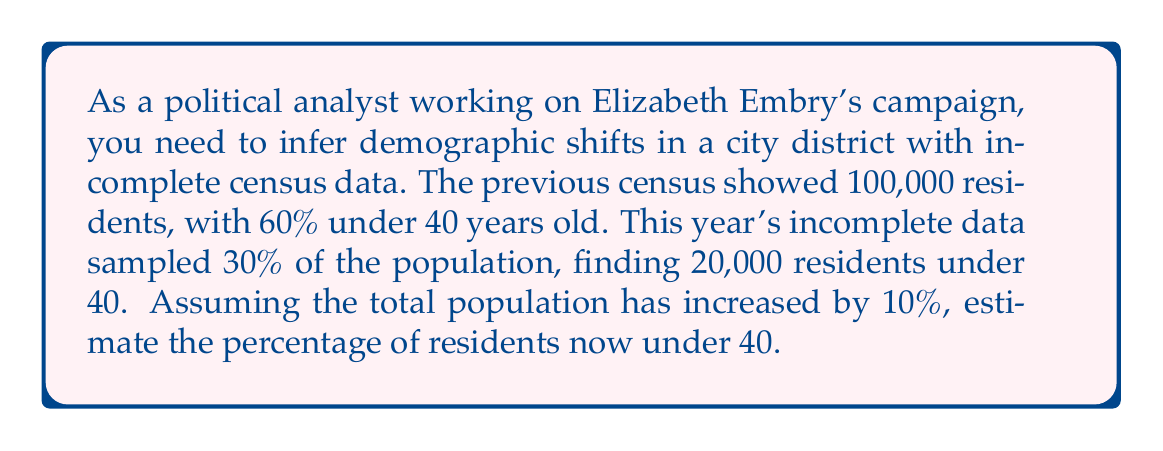Can you answer this question? Let's approach this step-by-step:

1) First, let's establish the known information:
   - Previous total population: 100,000
   - Previous percentage under 40: 60%
   - Current sample size: 30% of total population
   - Current sample under 40: 20,000
   - Total population increase: 10%

2) Calculate the new total population:
   $$ \text{New total} = 100,000 \times 1.10 = 110,000 $$

3) Calculate the size of the sample:
   $$ \text{Sample size} = 110,000 \times 0.30 = 33,000 $$

4) If 20,000 out of 33,000 sampled are under 40, we can estimate the total under 40:
   $$ \text{Total under 40} = 20,000 \times \frac{110,000}{33,000} \approx 66,667 $$

5) Calculate the percentage of the population under 40:
   $$ \text{Percentage under 40} = \frac{66,667}{110,000} \times 100\% \approx 60.61\% $$

This shows a slight increase in the percentage of residents under 40, from 60% to about 60.61%.
Answer: 60.61% 